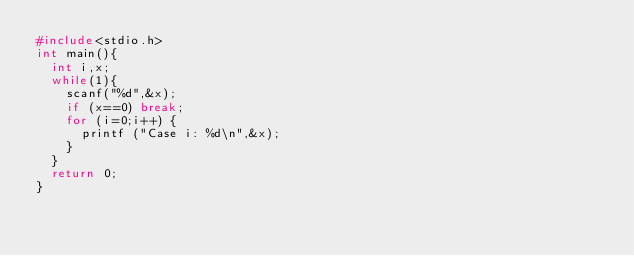Convert code to text. <code><loc_0><loc_0><loc_500><loc_500><_C_>#include<stdio.h>
int main(){
	int i,x;
	while(1){
		scanf("%d",&x);
		if (x==0) break;
		for (i=0;i++) {
			printf ("Case i: %d\n",&x);
		}
	}
	return 0;
}</code> 